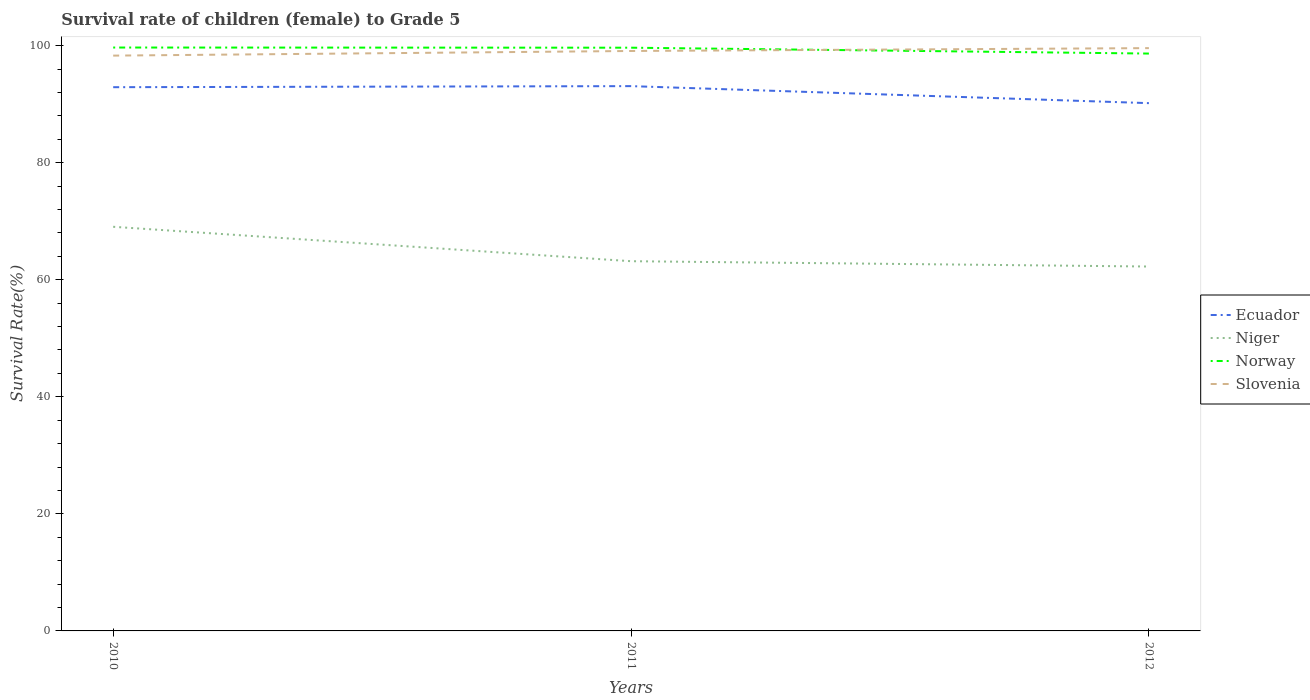Is the number of lines equal to the number of legend labels?
Offer a terse response. Yes. Across all years, what is the maximum survival rate of female children to grade 5 in Slovenia?
Ensure brevity in your answer.  98.3. In which year was the survival rate of female children to grade 5 in Ecuador maximum?
Your answer should be compact. 2012. What is the total survival rate of female children to grade 5 in Niger in the graph?
Make the answer very short. 5.88. What is the difference between the highest and the second highest survival rate of female children to grade 5 in Niger?
Offer a terse response. 6.79. What is the difference between the highest and the lowest survival rate of female children to grade 5 in Ecuador?
Make the answer very short. 2. How many lines are there?
Keep it short and to the point. 4. What is the difference between two consecutive major ticks on the Y-axis?
Offer a very short reply. 20. Are the values on the major ticks of Y-axis written in scientific E-notation?
Ensure brevity in your answer.  No. How many legend labels are there?
Make the answer very short. 4. How are the legend labels stacked?
Offer a terse response. Vertical. What is the title of the graph?
Offer a terse response. Survival rate of children (female) to Grade 5. Does "Pacific island small states" appear as one of the legend labels in the graph?
Provide a short and direct response. No. What is the label or title of the Y-axis?
Offer a terse response. Survival Rate(%). What is the Survival Rate(%) of Ecuador in 2010?
Offer a terse response. 92.9. What is the Survival Rate(%) of Niger in 2010?
Your response must be concise. 69.05. What is the Survival Rate(%) in Norway in 2010?
Provide a short and direct response. 99.68. What is the Survival Rate(%) in Slovenia in 2010?
Offer a very short reply. 98.3. What is the Survival Rate(%) of Ecuador in 2011?
Provide a succinct answer. 93.08. What is the Survival Rate(%) of Niger in 2011?
Provide a short and direct response. 63.17. What is the Survival Rate(%) in Norway in 2011?
Give a very brief answer. 99.65. What is the Survival Rate(%) in Slovenia in 2011?
Give a very brief answer. 99.09. What is the Survival Rate(%) of Ecuador in 2012?
Offer a terse response. 90.18. What is the Survival Rate(%) in Niger in 2012?
Keep it short and to the point. 62.26. What is the Survival Rate(%) in Norway in 2012?
Offer a very short reply. 98.65. What is the Survival Rate(%) in Slovenia in 2012?
Give a very brief answer. 99.58. Across all years, what is the maximum Survival Rate(%) in Ecuador?
Make the answer very short. 93.08. Across all years, what is the maximum Survival Rate(%) in Niger?
Offer a terse response. 69.05. Across all years, what is the maximum Survival Rate(%) of Norway?
Ensure brevity in your answer.  99.68. Across all years, what is the maximum Survival Rate(%) in Slovenia?
Give a very brief answer. 99.58. Across all years, what is the minimum Survival Rate(%) of Ecuador?
Your answer should be very brief. 90.18. Across all years, what is the minimum Survival Rate(%) of Niger?
Provide a short and direct response. 62.26. Across all years, what is the minimum Survival Rate(%) of Norway?
Offer a very short reply. 98.65. Across all years, what is the minimum Survival Rate(%) of Slovenia?
Make the answer very short. 98.3. What is the total Survival Rate(%) of Ecuador in the graph?
Your answer should be compact. 276.16. What is the total Survival Rate(%) in Niger in the graph?
Your answer should be compact. 194.48. What is the total Survival Rate(%) of Norway in the graph?
Provide a succinct answer. 297.98. What is the total Survival Rate(%) in Slovenia in the graph?
Your response must be concise. 296.97. What is the difference between the Survival Rate(%) in Ecuador in 2010 and that in 2011?
Provide a short and direct response. -0.18. What is the difference between the Survival Rate(%) in Niger in 2010 and that in 2011?
Provide a succinct answer. 5.88. What is the difference between the Survival Rate(%) in Norway in 2010 and that in 2011?
Offer a very short reply. 0.03. What is the difference between the Survival Rate(%) in Slovenia in 2010 and that in 2011?
Give a very brief answer. -0.79. What is the difference between the Survival Rate(%) of Ecuador in 2010 and that in 2012?
Offer a terse response. 2.73. What is the difference between the Survival Rate(%) of Niger in 2010 and that in 2012?
Offer a very short reply. 6.79. What is the difference between the Survival Rate(%) in Norway in 2010 and that in 2012?
Your answer should be very brief. 1.03. What is the difference between the Survival Rate(%) in Slovenia in 2010 and that in 2012?
Provide a succinct answer. -1.28. What is the difference between the Survival Rate(%) in Ecuador in 2011 and that in 2012?
Your response must be concise. 2.91. What is the difference between the Survival Rate(%) of Niger in 2011 and that in 2012?
Provide a succinct answer. 0.91. What is the difference between the Survival Rate(%) in Norway in 2011 and that in 2012?
Provide a short and direct response. 1. What is the difference between the Survival Rate(%) in Slovenia in 2011 and that in 2012?
Provide a succinct answer. -0.49. What is the difference between the Survival Rate(%) in Ecuador in 2010 and the Survival Rate(%) in Niger in 2011?
Make the answer very short. 29.73. What is the difference between the Survival Rate(%) of Ecuador in 2010 and the Survival Rate(%) of Norway in 2011?
Offer a terse response. -6.75. What is the difference between the Survival Rate(%) in Ecuador in 2010 and the Survival Rate(%) in Slovenia in 2011?
Give a very brief answer. -6.19. What is the difference between the Survival Rate(%) of Niger in 2010 and the Survival Rate(%) of Norway in 2011?
Provide a short and direct response. -30.6. What is the difference between the Survival Rate(%) in Niger in 2010 and the Survival Rate(%) in Slovenia in 2011?
Your answer should be compact. -30.04. What is the difference between the Survival Rate(%) of Norway in 2010 and the Survival Rate(%) of Slovenia in 2011?
Provide a succinct answer. 0.59. What is the difference between the Survival Rate(%) in Ecuador in 2010 and the Survival Rate(%) in Niger in 2012?
Your answer should be very brief. 30.64. What is the difference between the Survival Rate(%) in Ecuador in 2010 and the Survival Rate(%) in Norway in 2012?
Make the answer very short. -5.75. What is the difference between the Survival Rate(%) in Ecuador in 2010 and the Survival Rate(%) in Slovenia in 2012?
Your answer should be very brief. -6.68. What is the difference between the Survival Rate(%) of Niger in 2010 and the Survival Rate(%) of Norway in 2012?
Keep it short and to the point. -29.6. What is the difference between the Survival Rate(%) in Niger in 2010 and the Survival Rate(%) in Slovenia in 2012?
Your response must be concise. -30.53. What is the difference between the Survival Rate(%) in Norway in 2010 and the Survival Rate(%) in Slovenia in 2012?
Keep it short and to the point. 0.1. What is the difference between the Survival Rate(%) in Ecuador in 2011 and the Survival Rate(%) in Niger in 2012?
Keep it short and to the point. 30.82. What is the difference between the Survival Rate(%) in Ecuador in 2011 and the Survival Rate(%) in Norway in 2012?
Provide a succinct answer. -5.56. What is the difference between the Survival Rate(%) in Ecuador in 2011 and the Survival Rate(%) in Slovenia in 2012?
Ensure brevity in your answer.  -6.49. What is the difference between the Survival Rate(%) of Niger in 2011 and the Survival Rate(%) of Norway in 2012?
Make the answer very short. -35.48. What is the difference between the Survival Rate(%) of Niger in 2011 and the Survival Rate(%) of Slovenia in 2012?
Offer a terse response. -36.41. What is the difference between the Survival Rate(%) of Norway in 2011 and the Survival Rate(%) of Slovenia in 2012?
Provide a short and direct response. 0.07. What is the average Survival Rate(%) in Ecuador per year?
Provide a short and direct response. 92.05. What is the average Survival Rate(%) in Niger per year?
Your answer should be compact. 64.83. What is the average Survival Rate(%) of Norway per year?
Keep it short and to the point. 99.33. What is the average Survival Rate(%) of Slovenia per year?
Offer a very short reply. 98.99. In the year 2010, what is the difference between the Survival Rate(%) of Ecuador and Survival Rate(%) of Niger?
Offer a very short reply. 23.85. In the year 2010, what is the difference between the Survival Rate(%) in Ecuador and Survival Rate(%) in Norway?
Make the answer very short. -6.78. In the year 2010, what is the difference between the Survival Rate(%) of Ecuador and Survival Rate(%) of Slovenia?
Provide a succinct answer. -5.4. In the year 2010, what is the difference between the Survival Rate(%) of Niger and Survival Rate(%) of Norway?
Ensure brevity in your answer.  -30.63. In the year 2010, what is the difference between the Survival Rate(%) in Niger and Survival Rate(%) in Slovenia?
Make the answer very short. -29.25. In the year 2010, what is the difference between the Survival Rate(%) of Norway and Survival Rate(%) of Slovenia?
Give a very brief answer. 1.38. In the year 2011, what is the difference between the Survival Rate(%) of Ecuador and Survival Rate(%) of Niger?
Provide a succinct answer. 29.91. In the year 2011, what is the difference between the Survival Rate(%) of Ecuador and Survival Rate(%) of Norway?
Your answer should be compact. -6.57. In the year 2011, what is the difference between the Survival Rate(%) in Ecuador and Survival Rate(%) in Slovenia?
Your answer should be very brief. -6.01. In the year 2011, what is the difference between the Survival Rate(%) of Niger and Survival Rate(%) of Norway?
Provide a short and direct response. -36.48. In the year 2011, what is the difference between the Survival Rate(%) of Niger and Survival Rate(%) of Slovenia?
Offer a terse response. -35.92. In the year 2011, what is the difference between the Survival Rate(%) in Norway and Survival Rate(%) in Slovenia?
Ensure brevity in your answer.  0.56. In the year 2012, what is the difference between the Survival Rate(%) in Ecuador and Survival Rate(%) in Niger?
Your answer should be very brief. 27.91. In the year 2012, what is the difference between the Survival Rate(%) of Ecuador and Survival Rate(%) of Norway?
Keep it short and to the point. -8.47. In the year 2012, what is the difference between the Survival Rate(%) of Ecuador and Survival Rate(%) of Slovenia?
Make the answer very short. -9.4. In the year 2012, what is the difference between the Survival Rate(%) in Niger and Survival Rate(%) in Norway?
Provide a succinct answer. -36.39. In the year 2012, what is the difference between the Survival Rate(%) in Niger and Survival Rate(%) in Slovenia?
Make the answer very short. -37.32. In the year 2012, what is the difference between the Survival Rate(%) of Norway and Survival Rate(%) of Slovenia?
Your response must be concise. -0.93. What is the ratio of the Survival Rate(%) of Niger in 2010 to that in 2011?
Your answer should be very brief. 1.09. What is the ratio of the Survival Rate(%) of Ecuador in 2010 to that in 2012?
Keep it short and to the point. 1.03. What is the ratio of the Survival Rate(%) of Niger in 2010 to that in 2012?
Offer a terse response. 1.11. What is the ratio of the Survival Rate(%) of Norway in 2010 to that in 2012?
Ensure brevity in your answer.  1.01. What is the ratio of the Survival Rate(%) of Slovenia in 2010 to that in 2012?
Your answer should be very brief. 0.99. What is the ratio of the Survival Rate(%) of Ecuador in 2011 to that in 2012?
Keep it short and to the point. 1.03. What is the ratio of the Survival Rate(%) of Niger in 2011 to that in 2012?
Give a very brief answer. 1.01. What is the ratio of the Survival Rate(%) of Norway in 2011 to that in 2012?
Make the answer very short. 1.01. What is the difference between the highest and the second highest Survival Rate(%) in Ecuador?
Keep it short and to the point. 0.18. What is the difference between the highest and the second highest Survival Rate(%) of Niger?
Ensure brevity in your answer.  5.88. What is the difference between the highest and the second highest Survival Rate(%) of Norway?
Ensure brevity in your answer.  0.03. What is the difference between the highest and the second highest Survival Rate(%) in Slovenia?
Ensure brevity in your answer.  0.49. What is the difference between the highest and the lowest Survival Rate(%) of Ecuador?
Your answer should be very brief. 2.91. What is the difference between the highest and the lowest Survival Rate(%) in Niger?
Provide a short and direct response. 6.79. What is the difference between the highest and the lowest Survival Rate(%) in Norway?
Provide a short and direct response. 1.03. What is the difference between the highest and the lowest Survival Rate(%) of Slovenia?
Give a very brief answer. 1.28. 